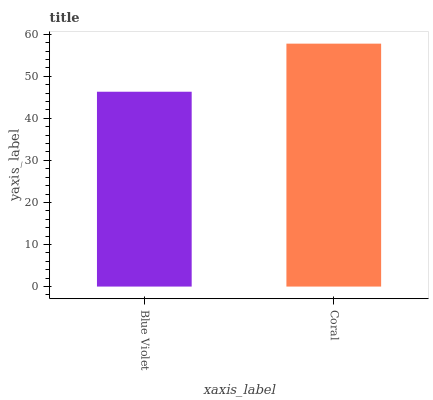Is Blue Violet the minimum?
Answer yes or no. Yes. Is Coral the maximum?
Answer yes or no. Yes. Is Coral the minimum?
Answer yes or no. No. Is Coral greater than Blue Violet?
Answer yes or no. Yes. Is Blue Violet less than Coral?
Answer yes or no. Yes. Is Blue Violet greater than Coral?
Answer yes or no. No. Is Coral less than Blue Violet?
Answer yes or no. No. Is Coral the high median?
Answer yes or no. Yes. Is Blue Violet the low median?
Answer yes or no. Yes. Is Blue Violet the high median?
Answer yes or no. No. Is Coral the low median?
Answer yes or no. No. 